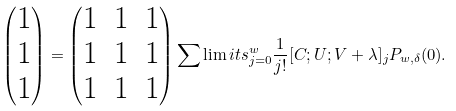<formula> <loc_0><loc_0><loc_500><loc_500>\left ( \begin{matrix} 1 \\ 1 \\ 1 \end{matrix} \right ) = \begin{pmatrix} 1 & 1 & 1 \\ 1 & 1 & 1 \\ 1 & 1 & 1 \end{pmatrix} \sum \lim i t s _ { j = 0 } ^ { w } \frac { 1 } { j ! } [ C ; U ; V + \lambda ] _ { j } P _ { w , \delta } ( 0 ) .</formula> 